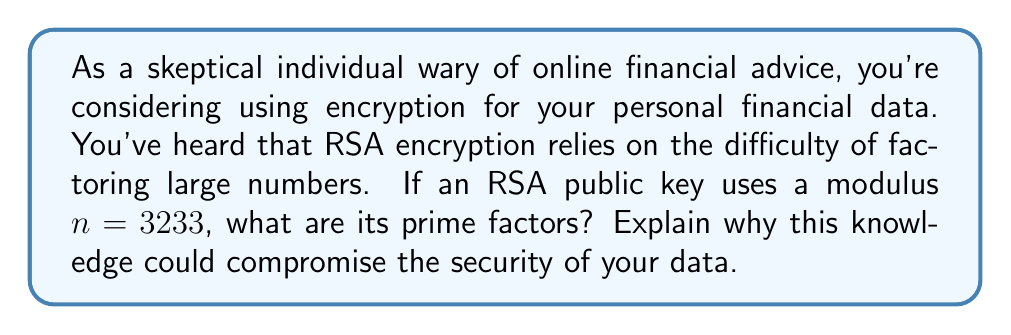Help me with this question. To understand why knowing the prime factors of the modulus $n$ in RSA encryption compromises security, let's break down the process:

1) In RSA, the modulus $n$ is the product of two prime numbers, $p$ and $q$. 

2) To factor $n = 3233$, we need to find its prime factors. We can do this by trial division:

   $3233 = 61 \times 53$

3) Therefore, $p = 61$ and $q = 53$.

4) In RSA, the public key consists of $n$ and an encryption exponent $e$. The private key is the decryption exponent $d$.

5) The security of RSA relies on the fact that it's computationally difficult to factor large $n$ values. However, if we know $p$ and $q$, we can easily compute:

   $\phi(n) = (p-1)(q-1) = 60 \times 52 = 3120$

6) With $\phi(n)$, we can easily find the private key $d$ using the extended Euclidean algorithm, given the public encryption exponent $e$.

7) Once an attacker has the private key, they can decrypt any message encrypted with the corresponding public key.

This demonstrates why using small prime factors (as in this example) is insecure. In practice, RSA uses prime numbers with hundreds of digits to make factorization computationally infeasible with current technology.

For your personal financial data, this means that if you use an RSA key with a small modulus, a determined attacker could potentially decrypt your sensitive information, compromising your financial security.
Answer: The prime factors of 3233 are 61 and 53. Knowledge of these factors compromises the security of the RSA encryption system by allowing the computation of $\phi(n)$, which in turn enables the calculation of the private key. 